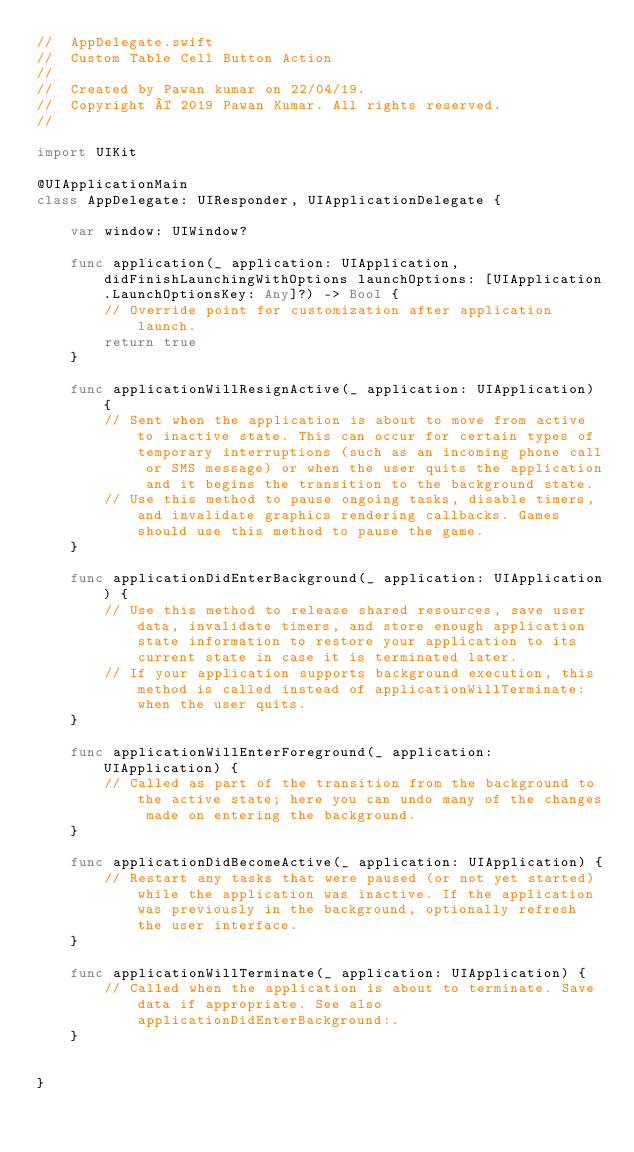<code> <loc_0><loc_0><loc_500><loc_500><_Swift_>//  AppDelegate.swift
//  Custom Table Cell Button Action
//
//  Created by Pawan kumar on 22/04/19.
//  Copyright © 2019 Pawan Kumar. All rights reserved.
//

import UIKit

@UIApplicationMain
class AppDelegate: UIResponder, UIApplicationDelegate {

    var window: UIWindow?

    func application(_ application: UIApplication, didFinishLaunchingWithOptions launchOptions: [UIApplication.LaunchOptionsKey: Any]?) -> Bool {
        // Override point for customization after application launch.
        return true
    }

    func applicationWillResignActive(_ application: UIApplication) {
        // Sent when the application is about to move from active to inactive state. This can occur for certain types of temporary interruptions (such as an incoming phone call or SMS message) or when the user quits the application and it begins the transition to the background state.
        // Use this method to pause ongoing tasks, disable timers, and invalidate graphics rendering callbacks. Games should use this method to pause the game.
    }

    func applicationDidEnterBackground(_ application: UIApplication) {
        // Use this method to release shared resources, save user data, invalidate timers, and store enough application state information to restore your application to its current state in case it is terminated later.
        // If your application supports background execution, this method is called instead of applicationWillTerminate: when the user quits.
    }

    func applicationWillEnterForeground(_ application: UIApplication) {
        // Called as part of the transition from the background to the active state; here you can undo many of the changes made on entering the background.
    }

    func applicationDidBecomeActive(_ application: UIApplication) {
        // Restart any tasks that were paused (or not yet started) while the application was inactive. If the application was previously in the background, optionally refresh the user interface.
    }

    func applicationWillTerminate(_ application: UIApplication) {
        // Called when the application is about to terminate. Save data if appropriate. See also applicationDidEnterBackground:.
    }


}

</code> 